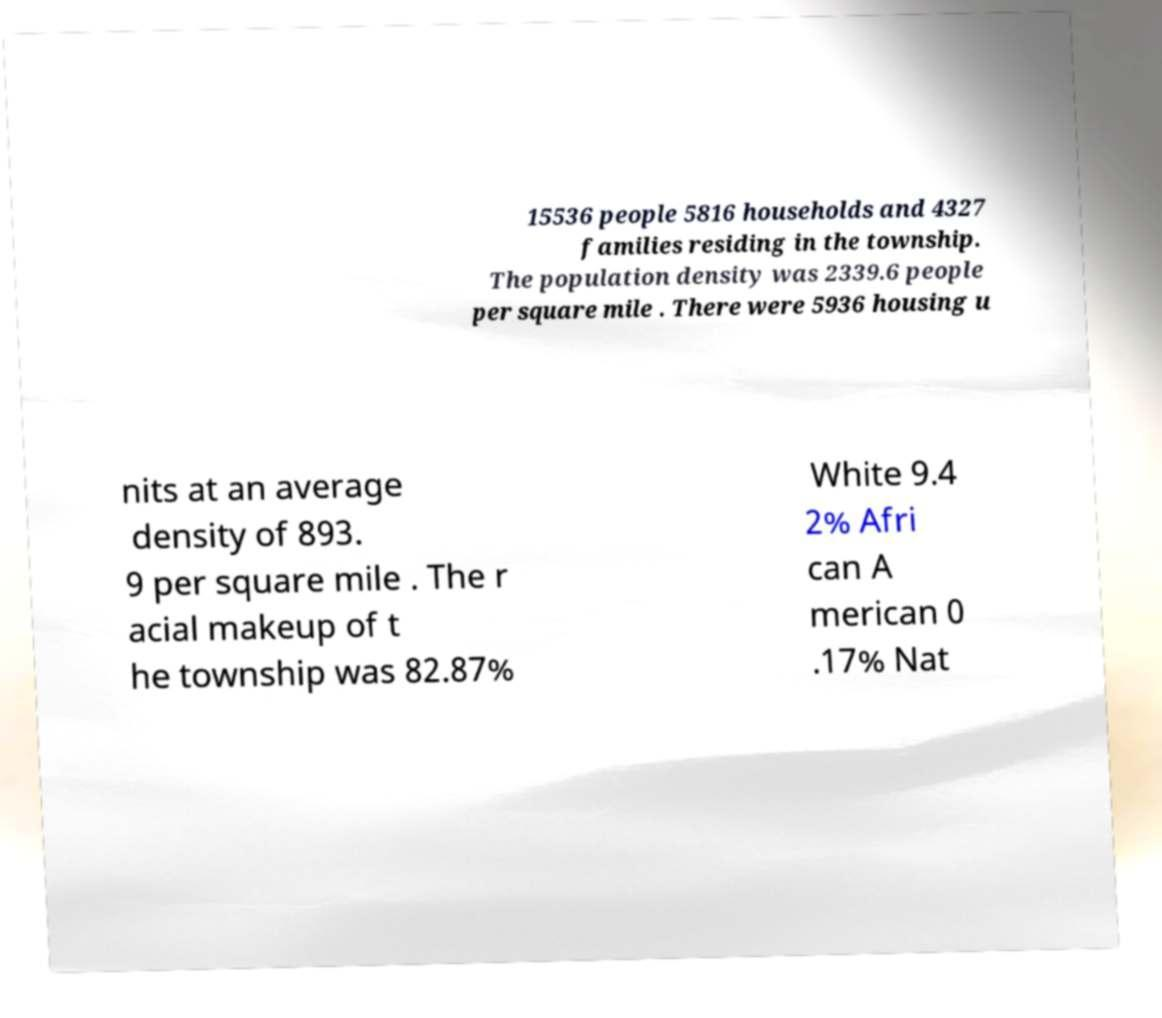For documentation purposes, I need the text within this image transcribed. Could you provide that? 15536 people 5816 households and 4327 families residing in the township. The population density was 2339.6 people per square mile . There were 5936 housing u nits at an average density of 893. 9 per square mile . The r acial makeup of t he township was 82.87% White 9.4 2% Afri can A merican 0 .17% Nat 